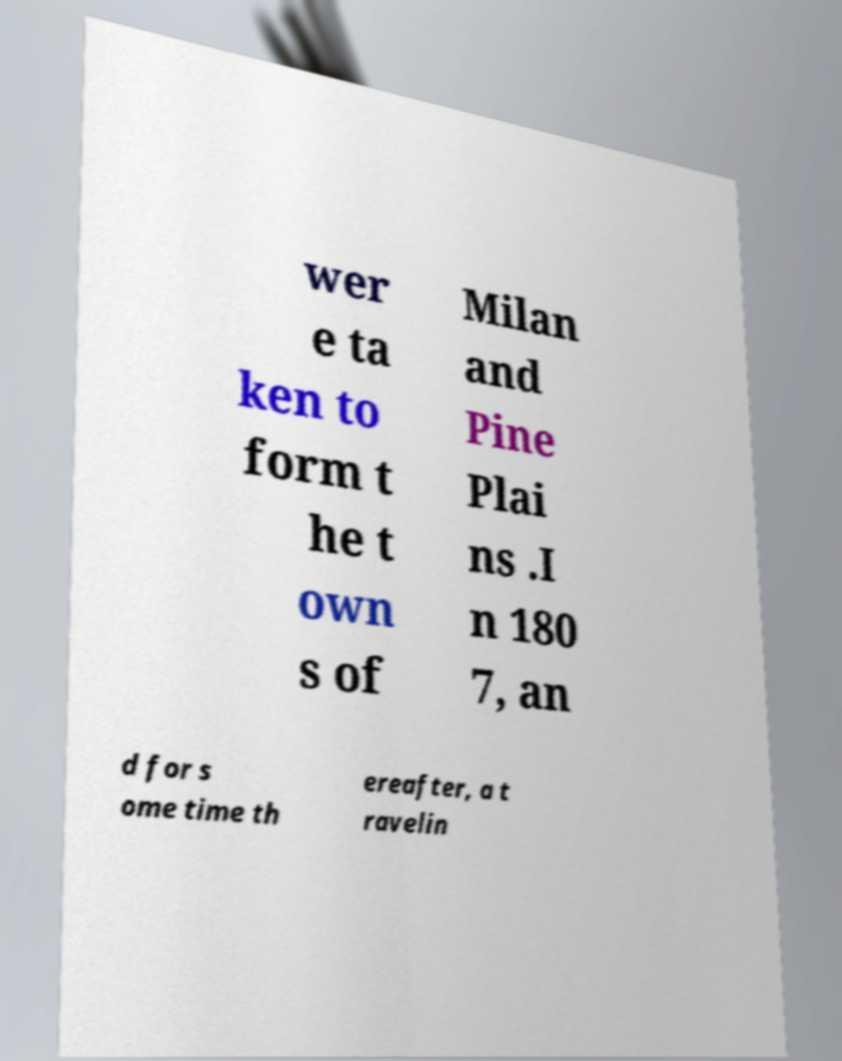Please read and relay the text visible in this image. What does it say? wer e ta ken to form t he t own s of Milan and Pine Plai ns .I n 180 7, an d for s ome time th ereafter, a t ravelin 